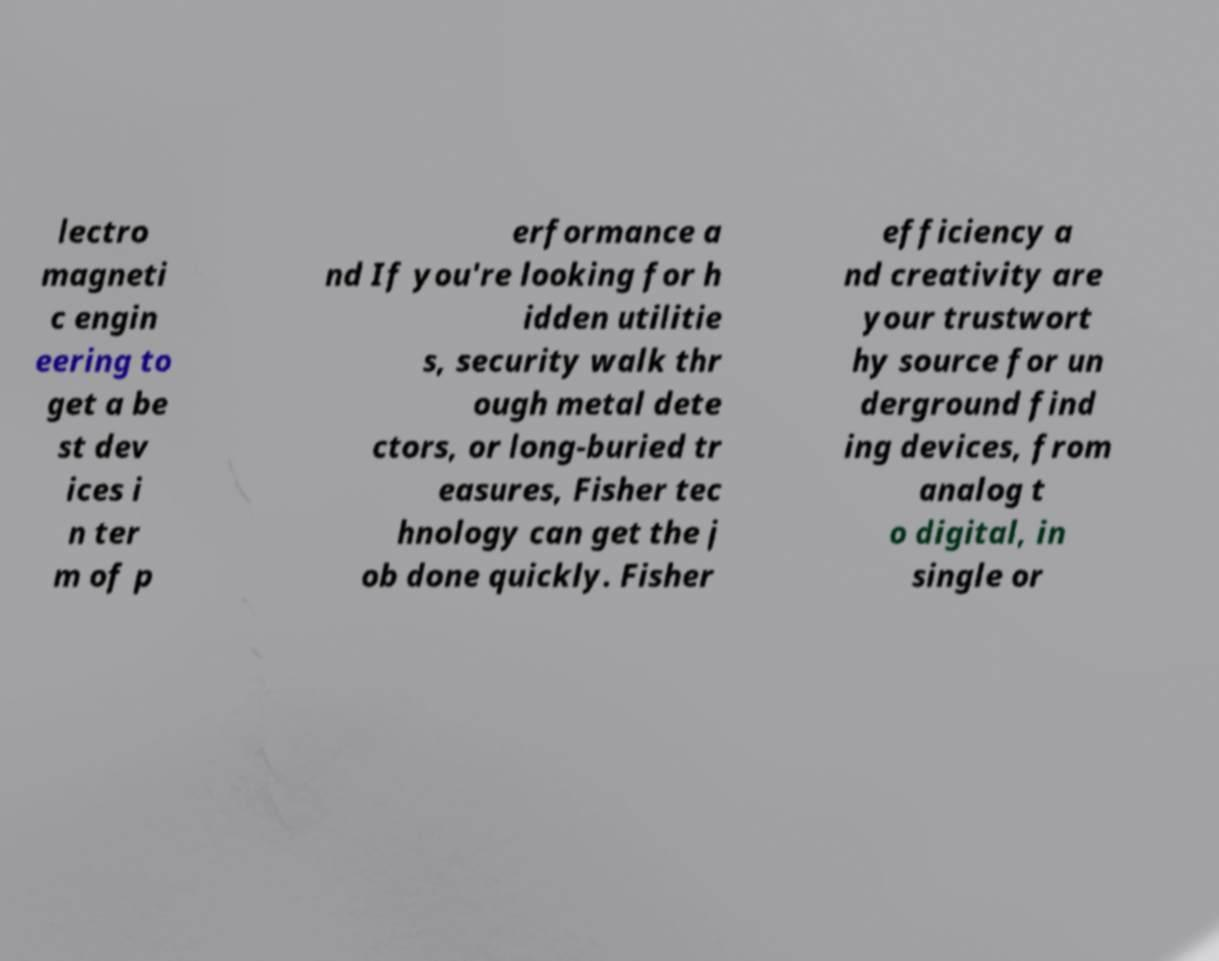I need the written content from this picture converted into text. Can you do that? lectro magneti c engin eering to get a be st dev ices i n ter m of p erformance a nd If you're looking for h idden utilitie s, security walk thr ough metal dete ctors, or long-buried tr easures, Fisher tec hnology can get the j ob done quickly. Fisher efficiency a nd creativity are your trustwort hy source for un derground find ing devices, from analog t o digital, in single or 